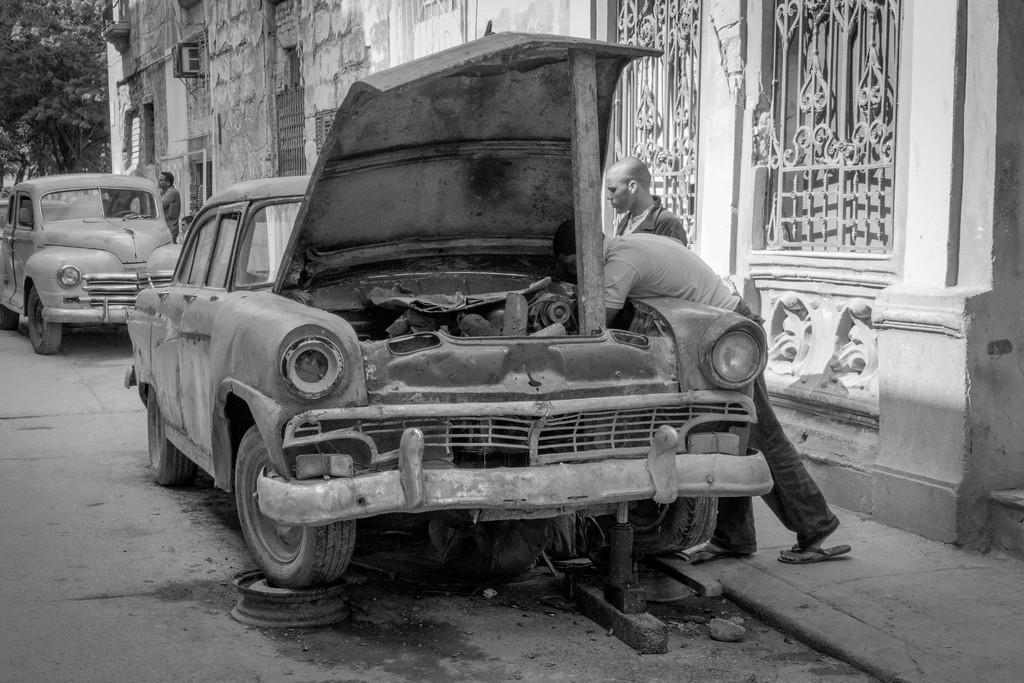Describe this image in one or two sentences. This is a black and white image. Here I can see two cars on the road. Beside the cars few people are standing on the footpath. In the background, I can see a building and trees. 